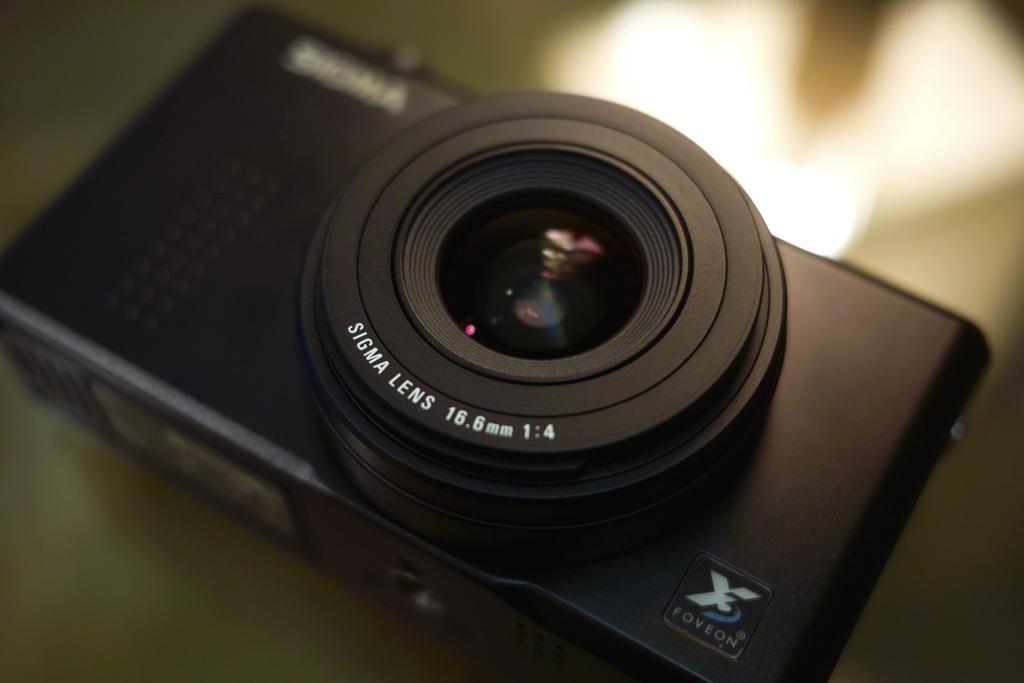How would you summarize this image in a sentence or two? As we can see in the image there is a table. On table there is black color camera. 